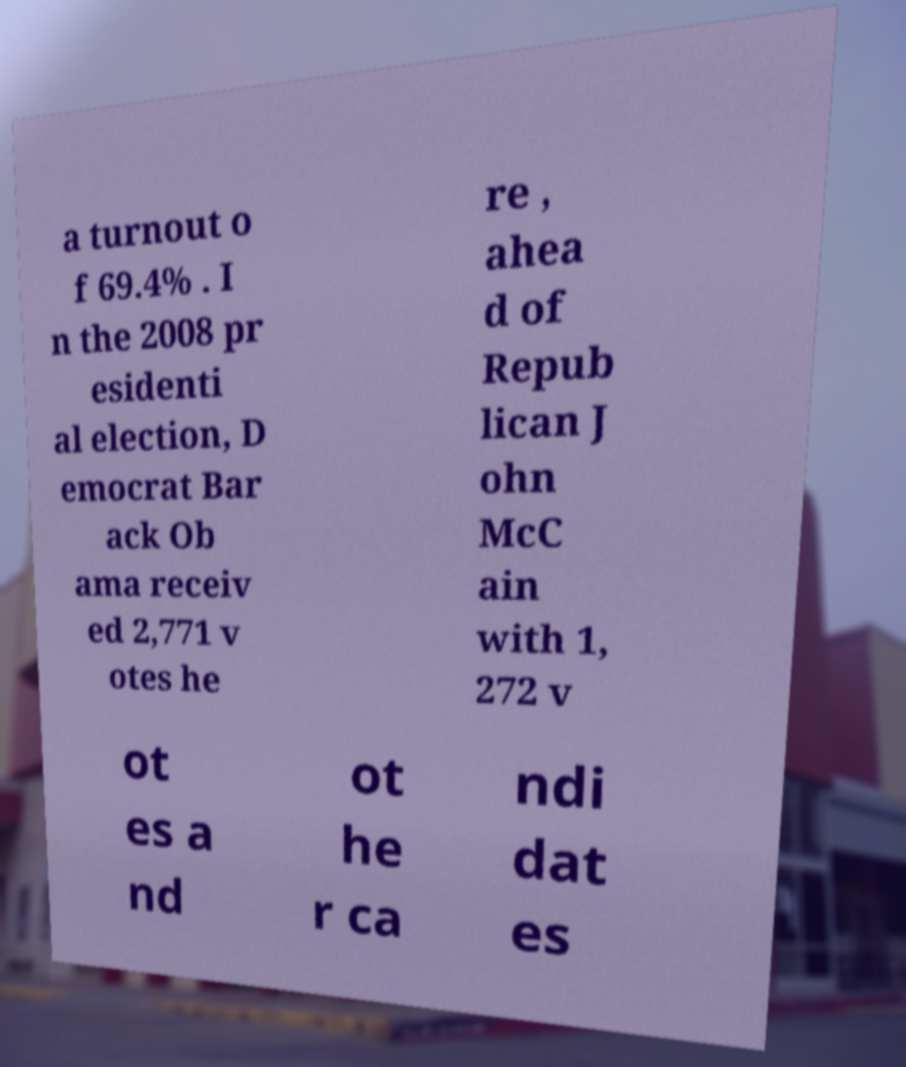I need the written content from this picture converted into text. Can you do that? a turnout o f 69.4% . I n the 2008 pr esidenti al election, D emocrat Bar ack Ob ama receiv ed 2,771 v otes he re , ahea d of Repub lican J ohn McC ain with 1, 272 v ot es a nd ot he r ca ndi dat es 